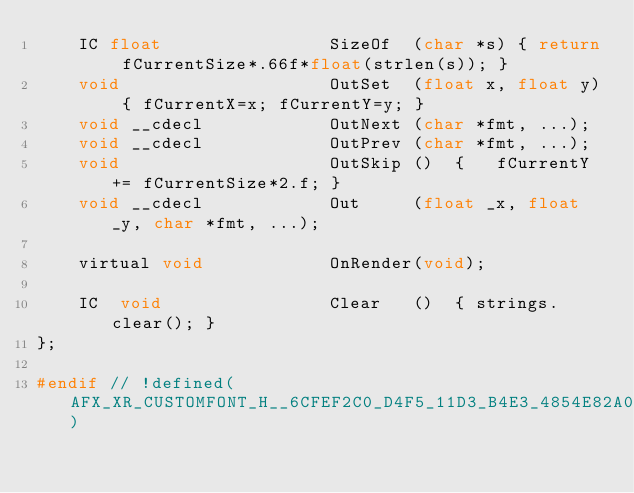<code> <loc_0><loc_0><loc_500><loc_500><_C_>	IC float				SizeOf	(char *s) { return fCurrentSize*.66f*float(strlen(s)); }
	void					OutSet	(float x, float y) { fCurrentX=x; fCurrentY=y; }
	void __cdecl            OutNext	(char *fmt, ...);
	void __cdecl            OutPrev	(char *fmt, ...);
	void					OutSkip	()	{ 	fCurrentY += fCurrentSize*2.f; }
	void __cdecl 			Out		(float _x, float _y, char *fmt, ...);

	virtual void			OnRender(void);

	IC	void				Clear	()  { strings.clear(); }
};

#endif // !defined(AFX_XR_CUSTOMFONT_H__6CFEF2C0_D4F5_11D3_B4E3_4854E82A090D__INCLUDED_)
</code> 